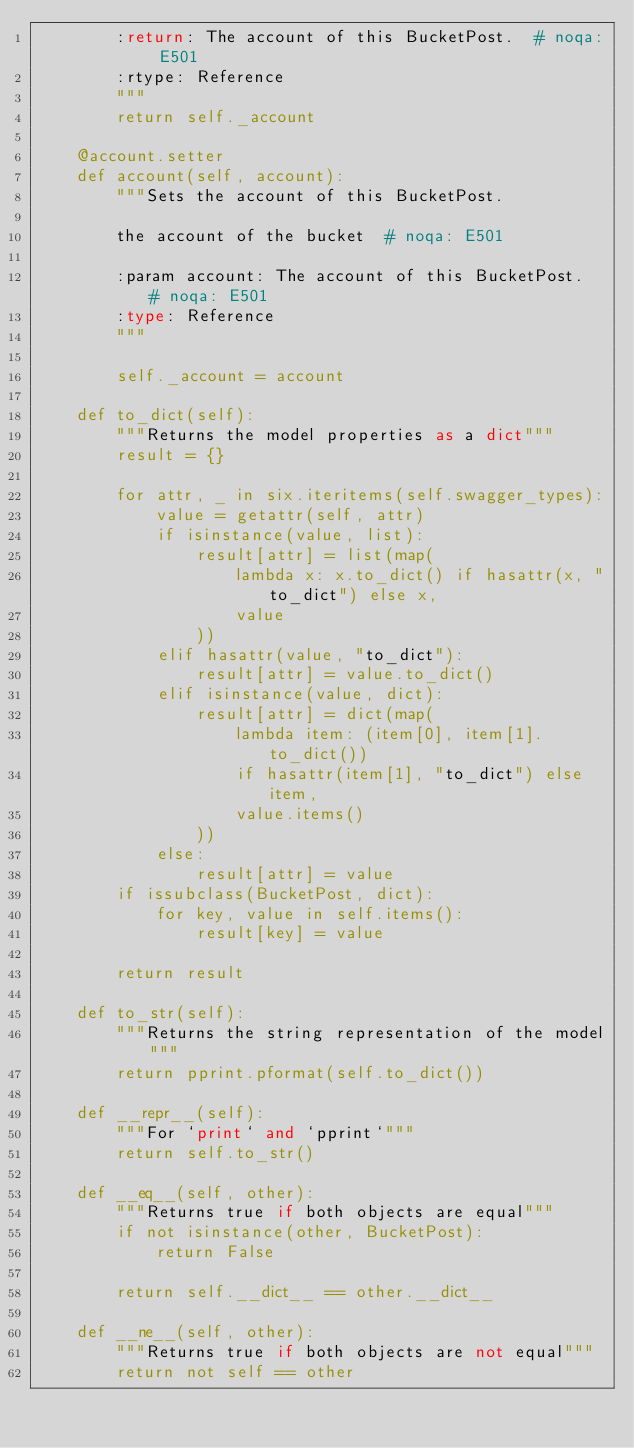<code> <loc_0><loc_0><loc_500><loc_500><_Python_>        :return: The account of this BucketPost.  # noqa: E501
        :rtype: Reference
        """
        return self._account

    @account.setter
    def account(self, account):
        """Sets the account of this BucketPost.

        the account of the bucket  # noqa: E501

        :param account: The account of this BucketPost.  # noqa: E501
        :type: Reference
        """

        self._account = account

    def to_dict(self):
        """Returns the model properties as a dict"""
        result = {}

        for attr, _ in six.iteritems(self.swagger_types):
            value = getattr(self, attr)
            if isinstance(value, list):
                result[attr] = list(map(
                    lambda x: x.to_dict() if hasattr(x, "to_dict") else x,
                    value
                ))
            elif hasattr(value, "to_dict"):
                result[attr] = value.to_dict()
            elif isinstance(value, dict):
                result[attr] = dict(map(
                    lambda item: (item[0], item[1].to_dict())
                    if hasattr(item[1], "to_dict") else item,
                    value.items()
                ))
            else:
                result[attr] = value
        if issubclass(BucketPost, dict):
            for key, value in self.items():
                result[key] = value

        return result

    def to_str(self):
        """Returns the string representation of the model"""
        return pprint.pformat(self.to_dict())

    def __repr__(self):
        """For `print` and `pprint`"""
        return self.to_str()

    def __eq__(self, other):
        """Returns true if both objects are equal"""
        if not isinstance(other, BucketPost):
            return False

        return self.__dict__ == other.__dict__

    def __ne__(self, other):
        """Returns true if both objects are not equal"""
        return not self == other
</code> 